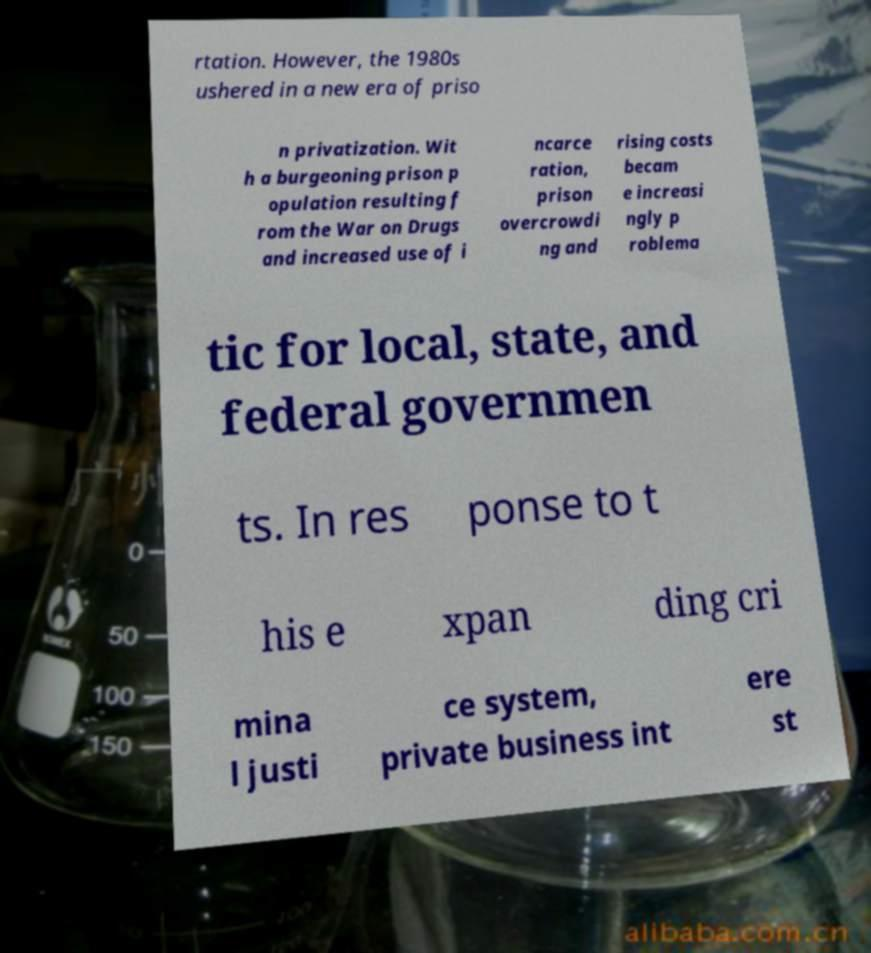For documentation purposes, I need the text within this image transcribed. Could you provide that? rtation. However, the 1980s ushered in a new era of priso n privatization. Wit h a burgeoning prison p opulation resulting f rom the War on Drugs and increased use of i ncarce ration, prison overcrowdi ng and rising costs becam e increasi ngly p roblema tic for local, state, and federal governmen ts. In res ponse to t his e xpan ding cri mina l justi ce system, private business int ere st 